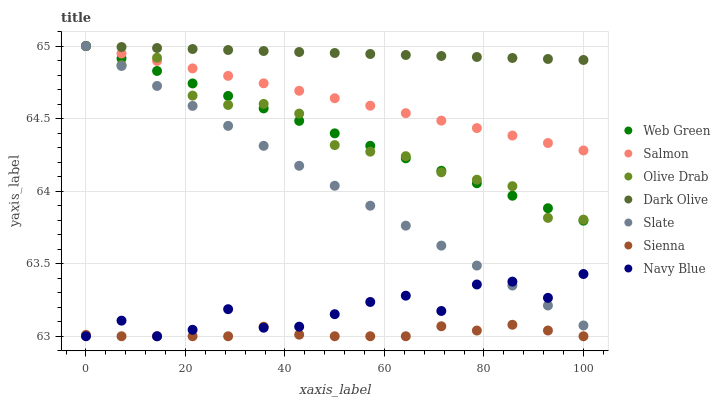Does Sienna have the minimum area under the curve?
Answer yes or no. Yes. Does Dark Olive have the maximum area under the curve?
Answer yes or no. Yes. Does Slate have the minimum area under the curve?
Answer yes or no. No. Does Slate have the maximum area under the curve?
Answer yes or no. No. Is Salmon the smoothest?
Answer yes or no. Yes. Is Navy Blue the roughest?
Answer yes or no. Yes. Is Slate the smoothest?
Answer yes or no. No. Is Slate the roughest?
Answer yes or no. No. Does Navy Blue have the lowest value?
Answer yes or no. Yes. Does Slate have the lowest value?
Answer yes or no. No. Does Olive Drab have the highest value?
Answer yes or no. Yes. Does Sienna have the highest value?
Answer yes or no. No. Is Sienna less than Dark Olive?
Answer yes or no. Yes. Is Olive Drab greater than Navy Blue?
Answer yes or no. Yes. Does Dark Olive intersect Salmon?
Answer yes or no. Yes. Is Dark Olive less than Salmon?
Answer yes or no. No. Is Dark Olive greater than Salmon?
Answer yes or no. No. Does Sienna intersect Dark Olive?
Answer yes or no. No. 